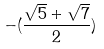<formula> <loc_0><loc_0><loc_500><loc_500>- ( \frac { \sqrt { 5 } + \sqrt { 7 } } { 2 } )</formula> 